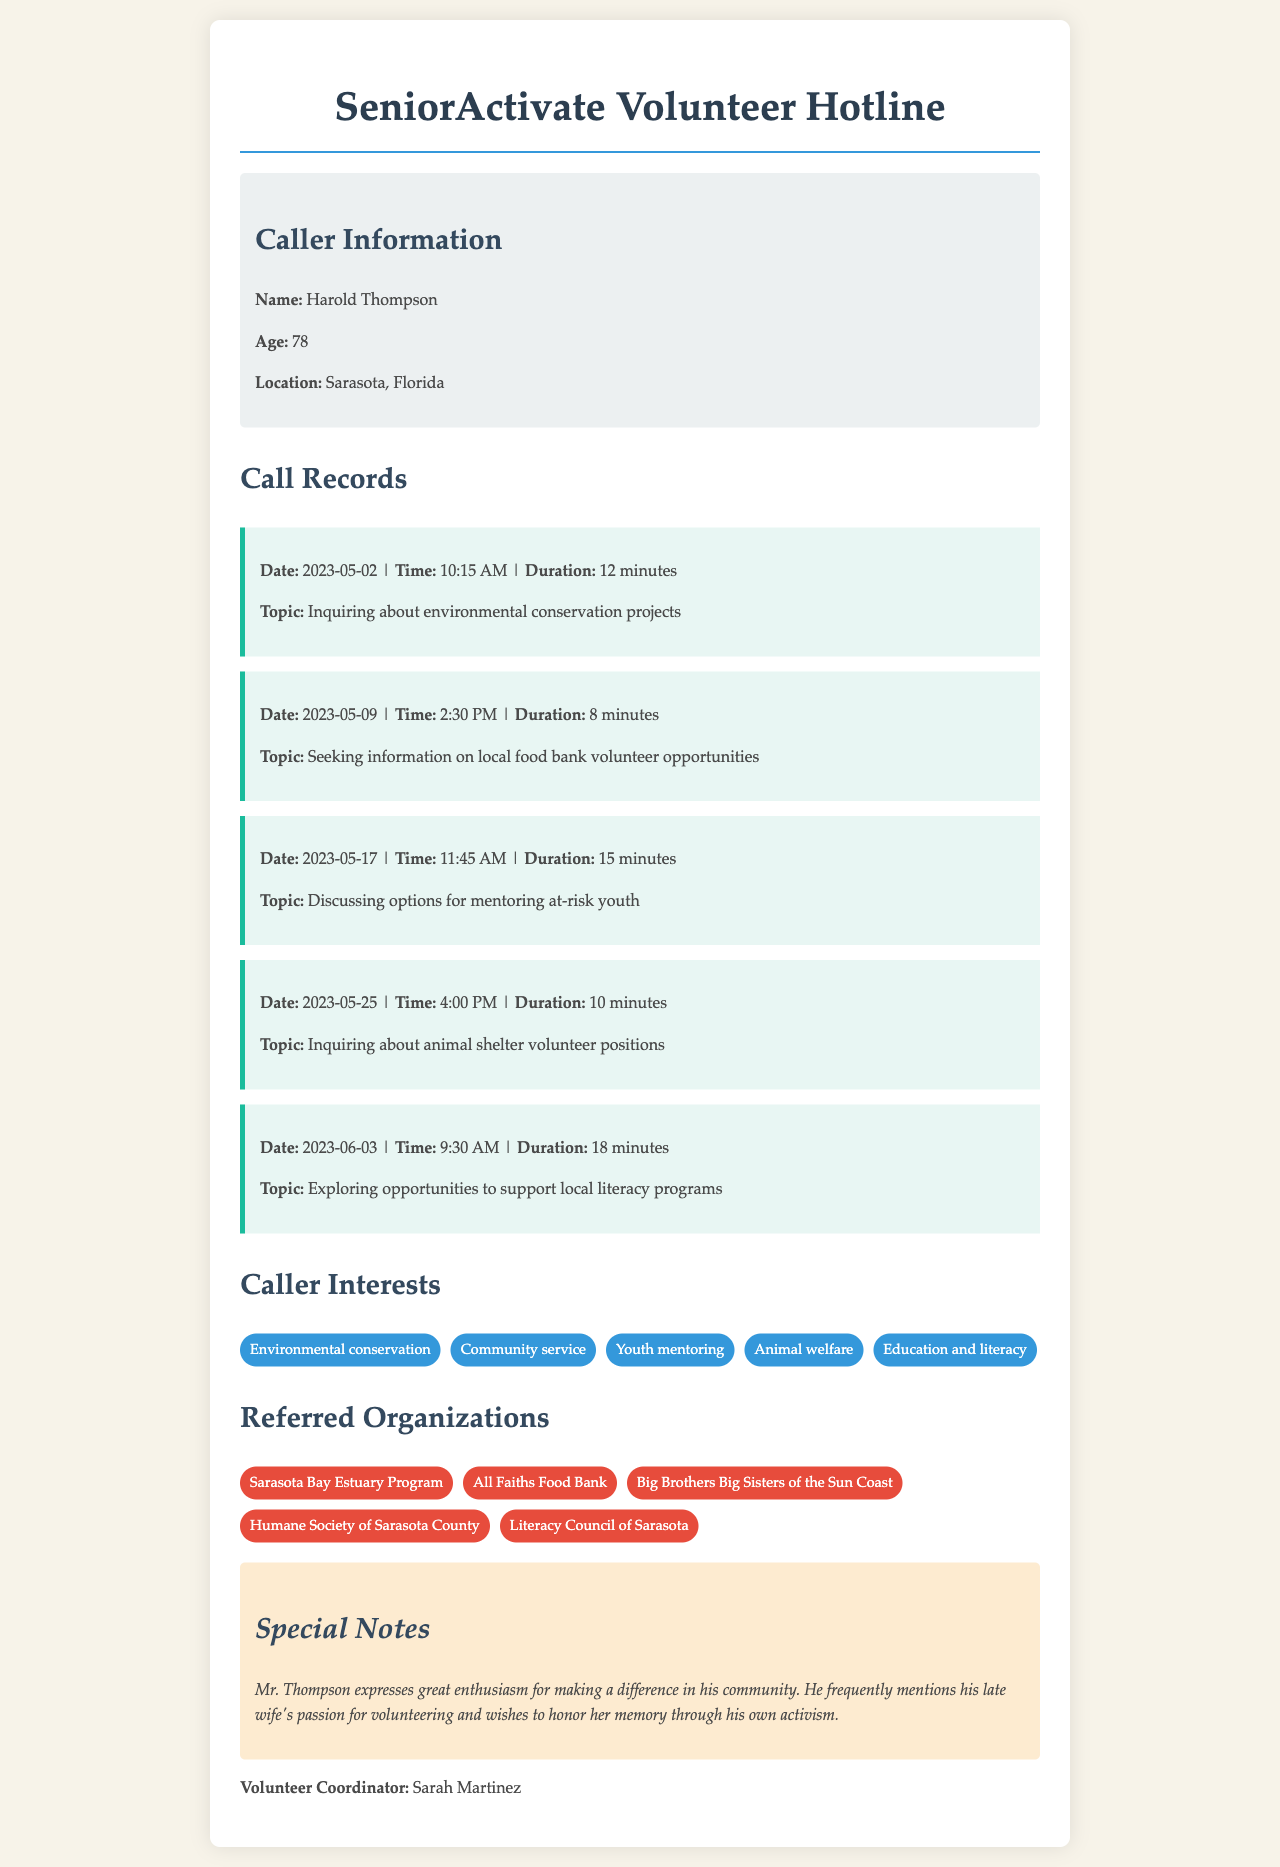What is the name of the caller? The name of the caller is prominently displayed in the header of the document.
Answer: Harold Thompson What is the age of the caller? The age of the caller is provided in the caller information section.
Answer: 78 What was the duration of the call on May 9, 2023? The duration is mentioned for each call in the call records section.
Answer: 8 minutes What organization was referred for environmental conservation? The referred organizations related to environmental causes are listed, and one matches this topic.
Answer: Sarasota Bay Estuary Program What topic did Mr. Thompson inquire about on May 25, 2023? Each call record details the specific topic of inquiry for that date.
Answer: Animal shelter volunteer positions How many interests are listed under Caller Interests? The interests are collectively presented, allowing for a quick count.
Answer: 5 Why does Mr. Thompson wish to volunteer? The special notes section contains insights into his motivations for volunteering.
Answer: Honor his late wife's memory Who is the volunteer coordinator? The name of the volunteer coordinator is indicated at the end of the document.
Answer: Sarah Martinez 